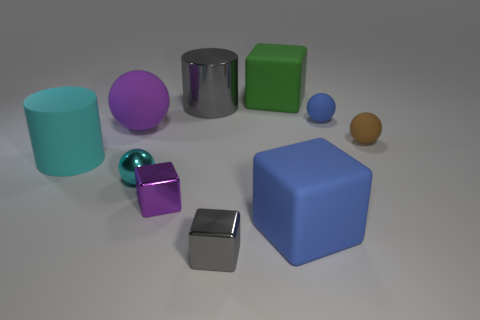Subtract all purple shiny blocks. How many blocks are left? 3 Subtract 1 cubes. How many cubes are left? 3 Subtract all yellow blocks. Subtract all green balls. How many blocks are left? 4 Subtract all blocks. How many objects are left? 6 Add 1 gray cylinders. How many gray cylinders are left? 2 Add 4 big purple rubber things. How many big purple rubber things exist? 5 Subtract 0 yellow balls. How many objects are left? 10 Subtract all small brown objects. Subtract all rubber objects. How many objects are left? 3 